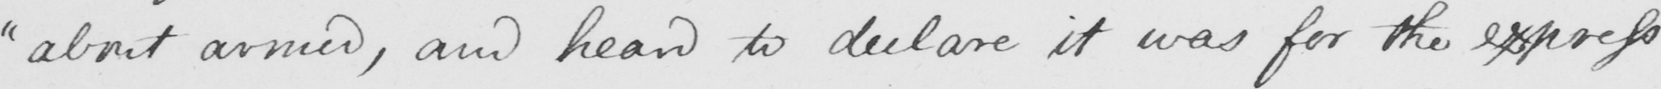What is written in this line of handwriting? " about armed , and heard to declare it was for the express 